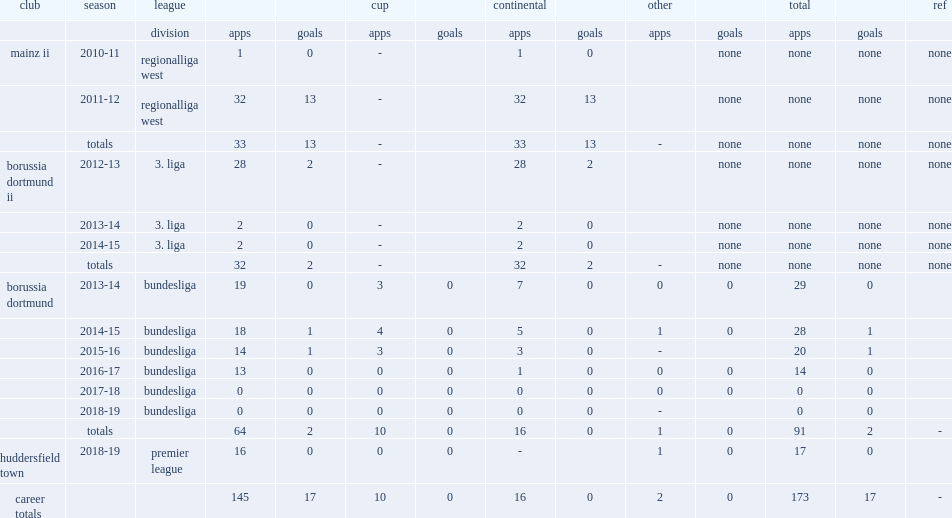In which league's 2013-14 season did durm play in borussia dortmund's team? Bundesliga. 